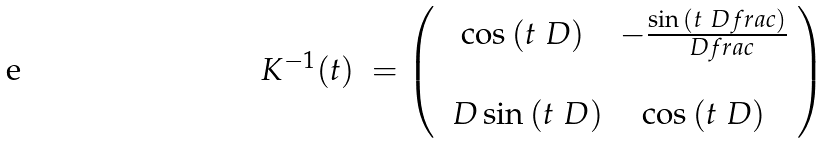<formula> <loc_0><loc_0><loc_500><loc_500>\begin{array} { l l } K ^ { - 1 } ( t ) & = \left ( \begin{array} { c c } \cos { ( t \ D ) } & - \frac { \sin { ( t \ D f r a c ) } } { \ D f r a c } \\ & \\ \ D \sin { ( t \ D ) } & \cos { ( t \ D ) } \end{array} \right ) \end{array}</formula> 